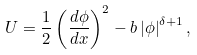<formula> <loc_0><loc_0><loc_500><loc_500>U = \frac { 1 } { 2 } \left ( \frac { d \phi } { d x } \right ) ^ { 2 } - b \left | \phi \right | ^ { \delta + 1 } ,</formula> 